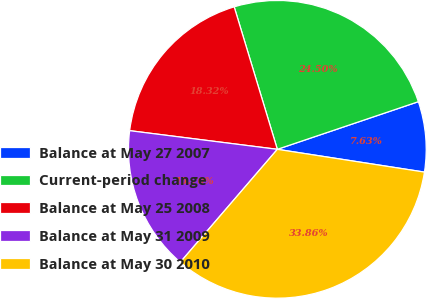Convert chart to OTSL. <chart><loc_0><loc_0><loc_500><loc_500><pie_chart><fcel>Balance at May 27 2007<fcel>Current-period change<fcel>Balance at May 25 2008<fcel>Balance at May 31 2009<fcel>Balance at May 30 2010<nl><fcel>7.63%<fcel>24.5%<fcel>18.32%<fcel>15.7%<fcel>33.86%<nl></chart> 